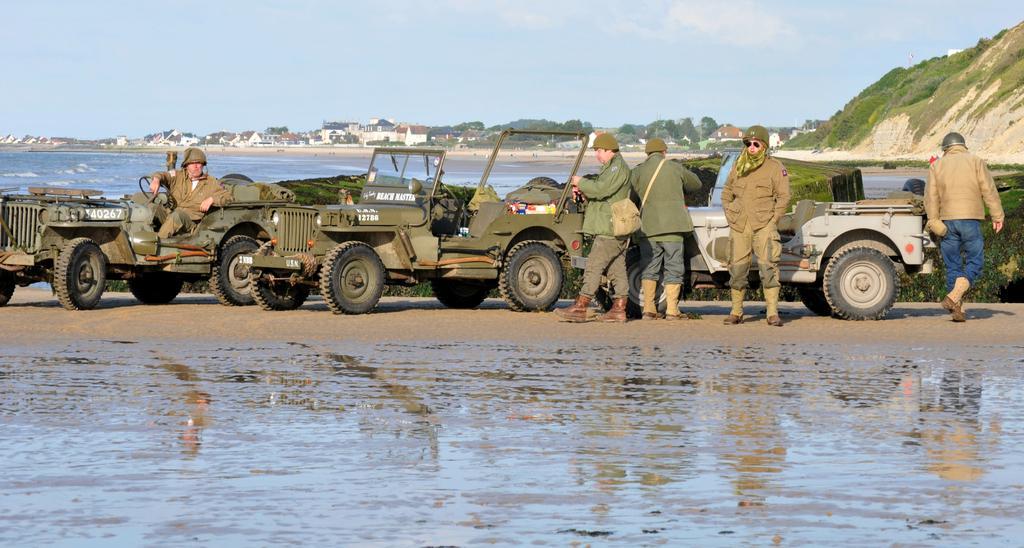Could you give a brief overview of what you see in this image? In this image I can see water, few vehicles, few people, number of trees, number of buildings, the sky and here I can see one is sitting and rest all are standing. I can see all of them are wearing helmets and he is carrying a bag. 